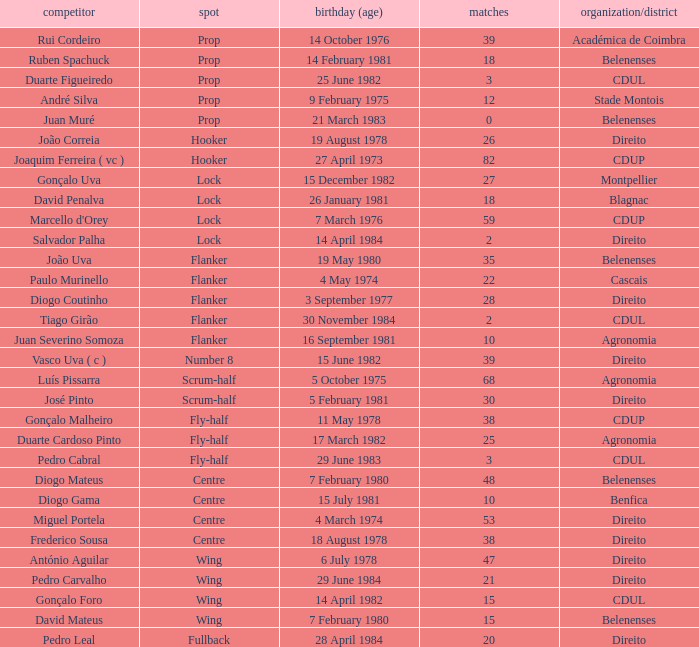How many caps have a Position of prop, and a Player of rui cordeiro? 1.0. 